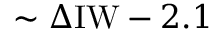Convert formula to latex. <formula><loc_0><loc_0><loc_500><loc_500>\sim \Delta I W - 2 . 1</formula> 